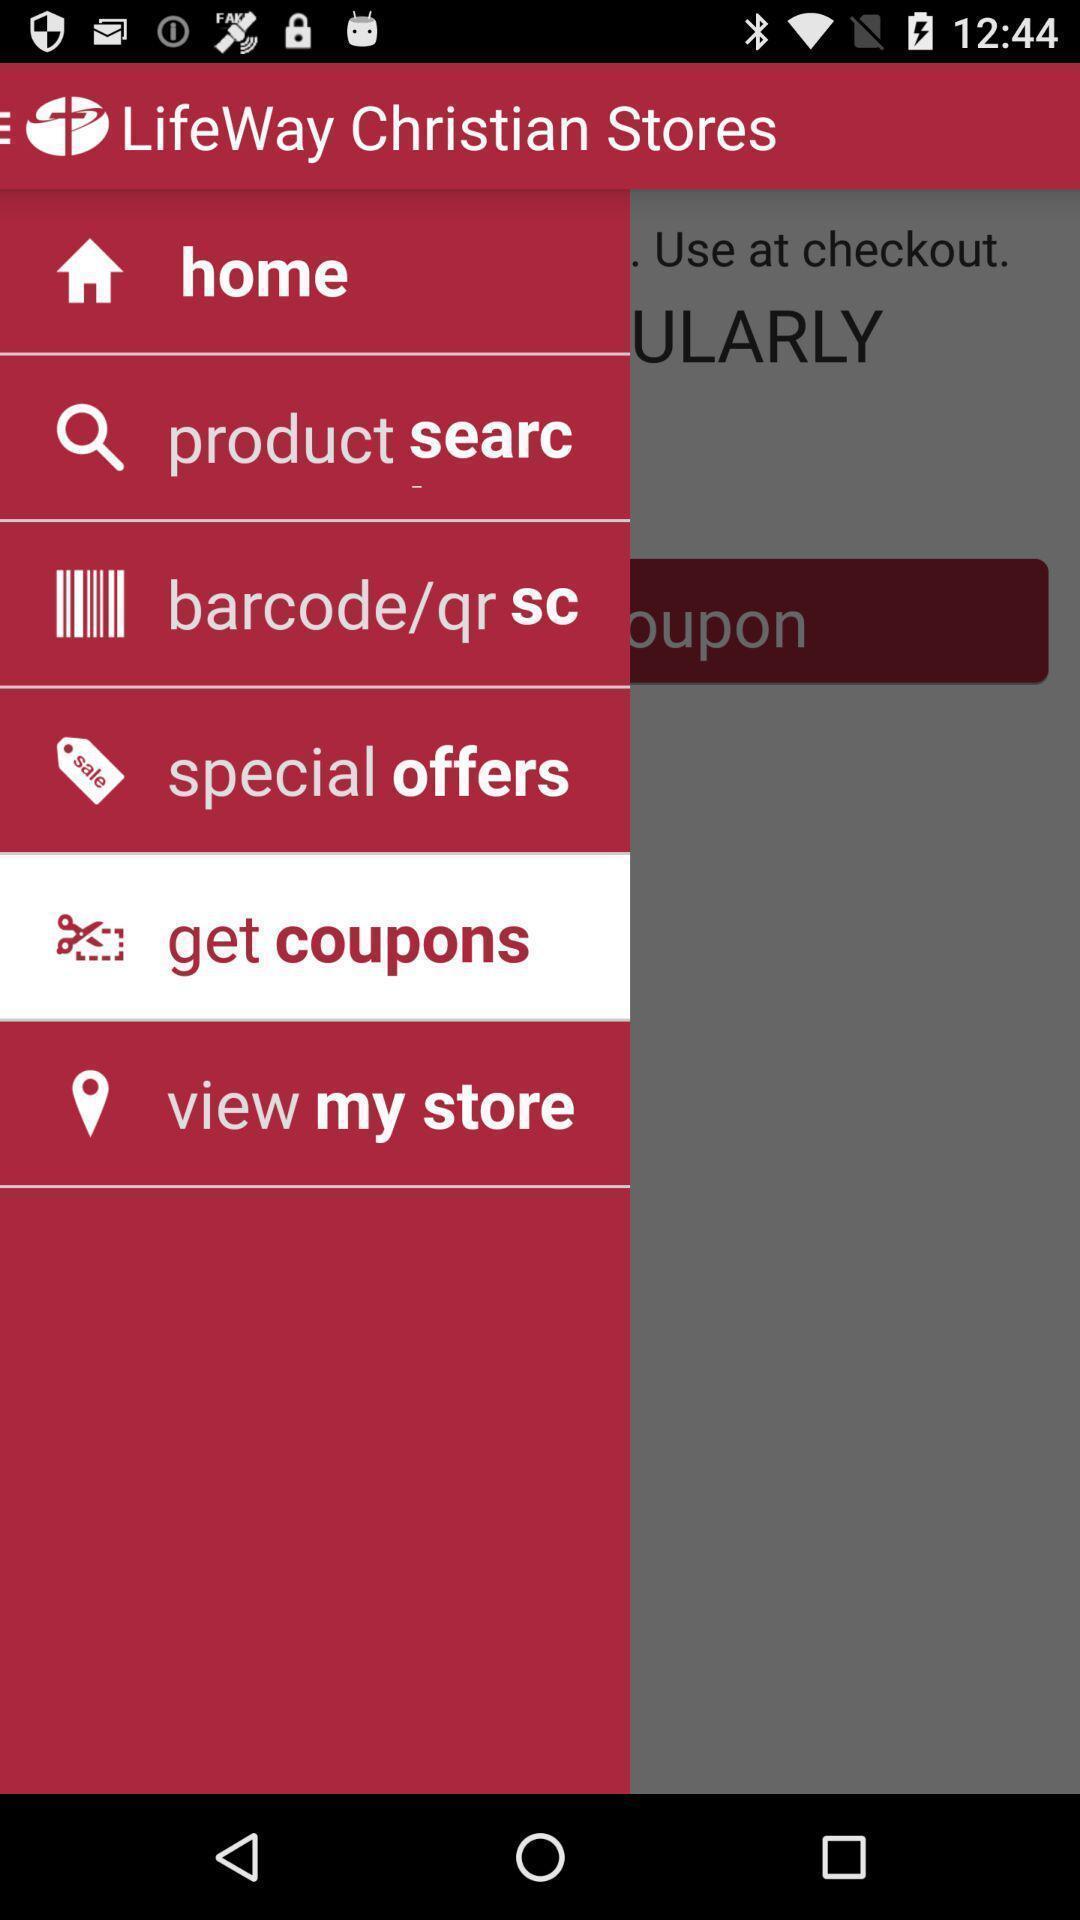What details can you identify in this image? Push up page displayed includes various options of religious app. 